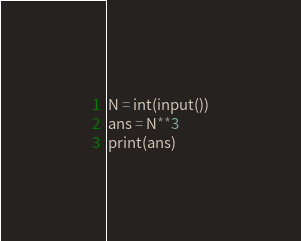<code> <loc_0><loc_0><loc_500><loc_500><_Python_>N = int(input())
ans = N**3
print(ans)
</code> 